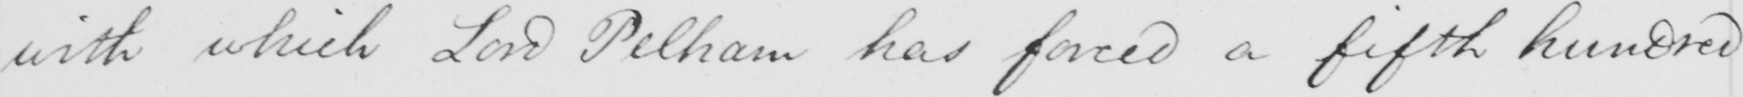Can you read and transcribe this handwriting? with which Lord Pelham has forced a fifth hundred 